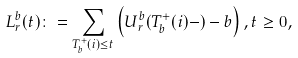<formula> <loc_0><loc_0><loc_500><loc_500>L _ { r } ^ { b } ( t ) \colon = \sum _ { T _ { b } ^ { + } ( i ) \leq t } \left ( U _ { r } ^ { b } ( T _ { b } ^ { + } ( i ) - ) - b \right ) , t \geq 0 ,</formula> 